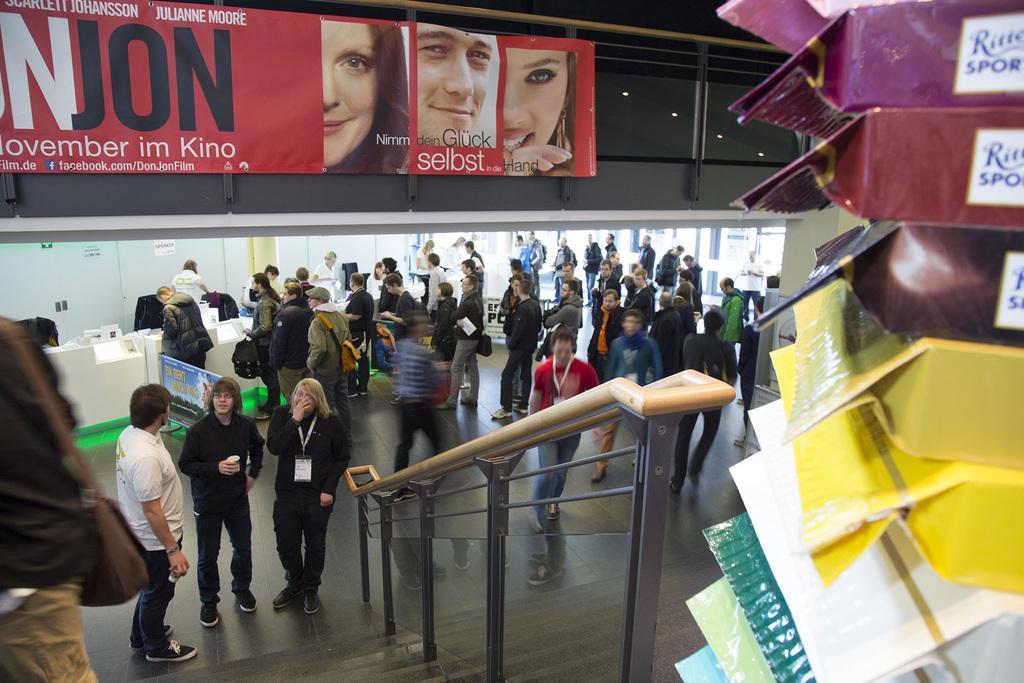Please provide a concise description of this image. Here we can see group of people on the floor. Here we can see boards, lights, and glasses. 